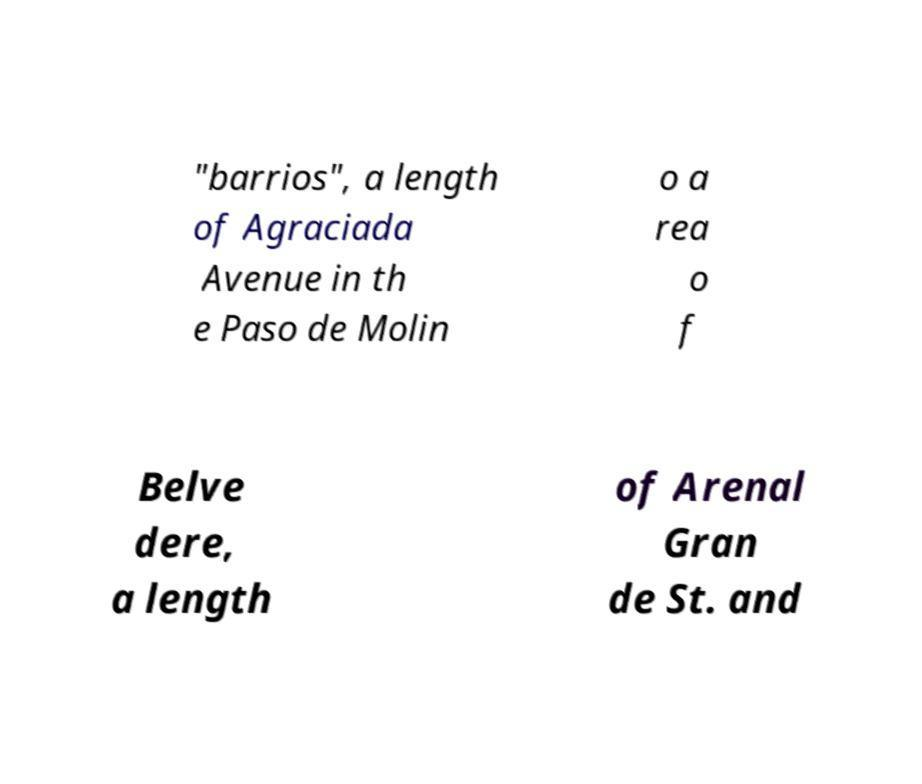There's text embedded in this image that I need extracted. Can you transcribe it verbatim? "barrios", a length of Agraciada Avenue in th e Paso de Molin o a rea o f Belve dere, a length of Arenal Gran de St. and 